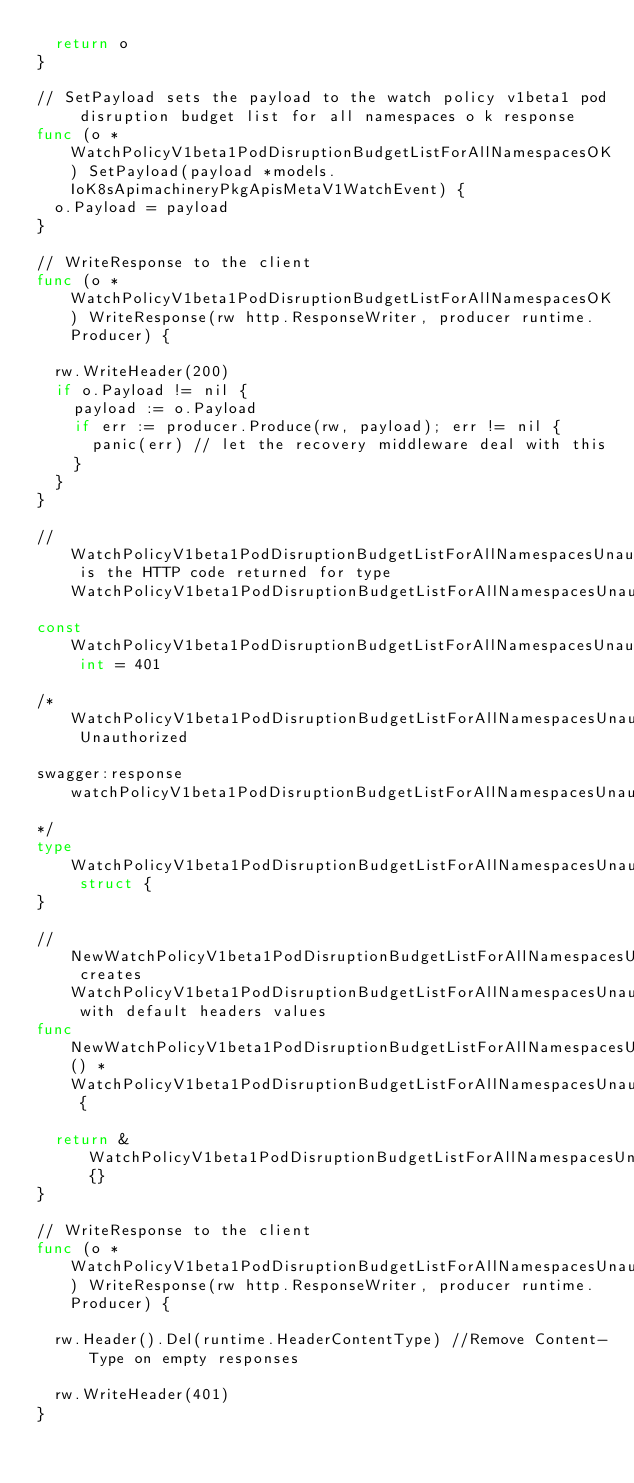Convert code to text. <code><loc_0><loc_0><loc_500><loc_500><_Go_>	return o
}

// SetPayload sets the payload to the watch policy v1beta1 pod disruption budget list for all namespaces o k response
func (o *WatchPolicyV1beta1PodDisruptionBudgetListForAllNamespacesOK) SetPayload(payload *models.IoK8sApimachineryPkgApisMetaV1WatchEvent) {
	o.Payload = payload
}

// WriteResponse to the client
func (o *WatchPolicyV1beta1PodDisruptionBudgetListForAllNamespacesOK) WriteResponse(rw http.ResponseWriter, producer runtime.Producer) {

	rw.WriteHeader(200)
	if o.Payload != nil {
		payload := o.Payload
		if err := producer.Produce(rw, payload); err != nil {
			panic(err) // let the recovery middleware deal with this
		}
	}
}

// WatchPolicyV1beta1PodDisruptionBudgetListForAllNamespacesUnauthorizedCode is the HTTP code returned for type WatchPolicyV1beta1PodDisruptionBudgetListForAllNamespacesUnauthorized
const WatchPolicyV1beta1PodDisruptionBudgetListForAllNamespacesUnauthorizedCode int = 401

/*WatchPolicyV1beta1PodDisruptionBudgetListForAllNamespacesUnauthorized Unauthorized

swagger:response watchPolicyV1beta1PodDisruptionBudgetListForAllNamespacesUnauthorized
*/
type WatchPolicyV1beta1PodDisruptionBudgetListForAllNamespacesUnauthorized struct {
}

// NewWatchPolicyV1beta1PodDisruptionBudgetListForAllNamespacesUnauthorized creates WatchPolicyV1beta1PodDisruptionBudgetListForAllNamespacesUnauthorized with default headers values
func NewWatchPolicyV1beta1PodDisruptionBudgetListForAllNamespacesUnauthorized() *WatchPolicyV1beta1PodDisruptionBudgetListForAllNamespacesUnauthorized {

	return &WatchPolicyV1beta1PodDisruptionBudgetListForAllNamespacesUnauthorized{}
}

// WriteResponse to the client
func (o *WatchPolicyV1beta1PodDisruptionBudgetListForAllNamespacesUnauthorized) WriteResponse(rw http.ResponseWriter, producer runtime.Producer) {

	rw.Header().Del(runtime.HeaderContentType) //Remove Content-Type on empty responses

	rw.WriteHeader(401)
}
</code> 